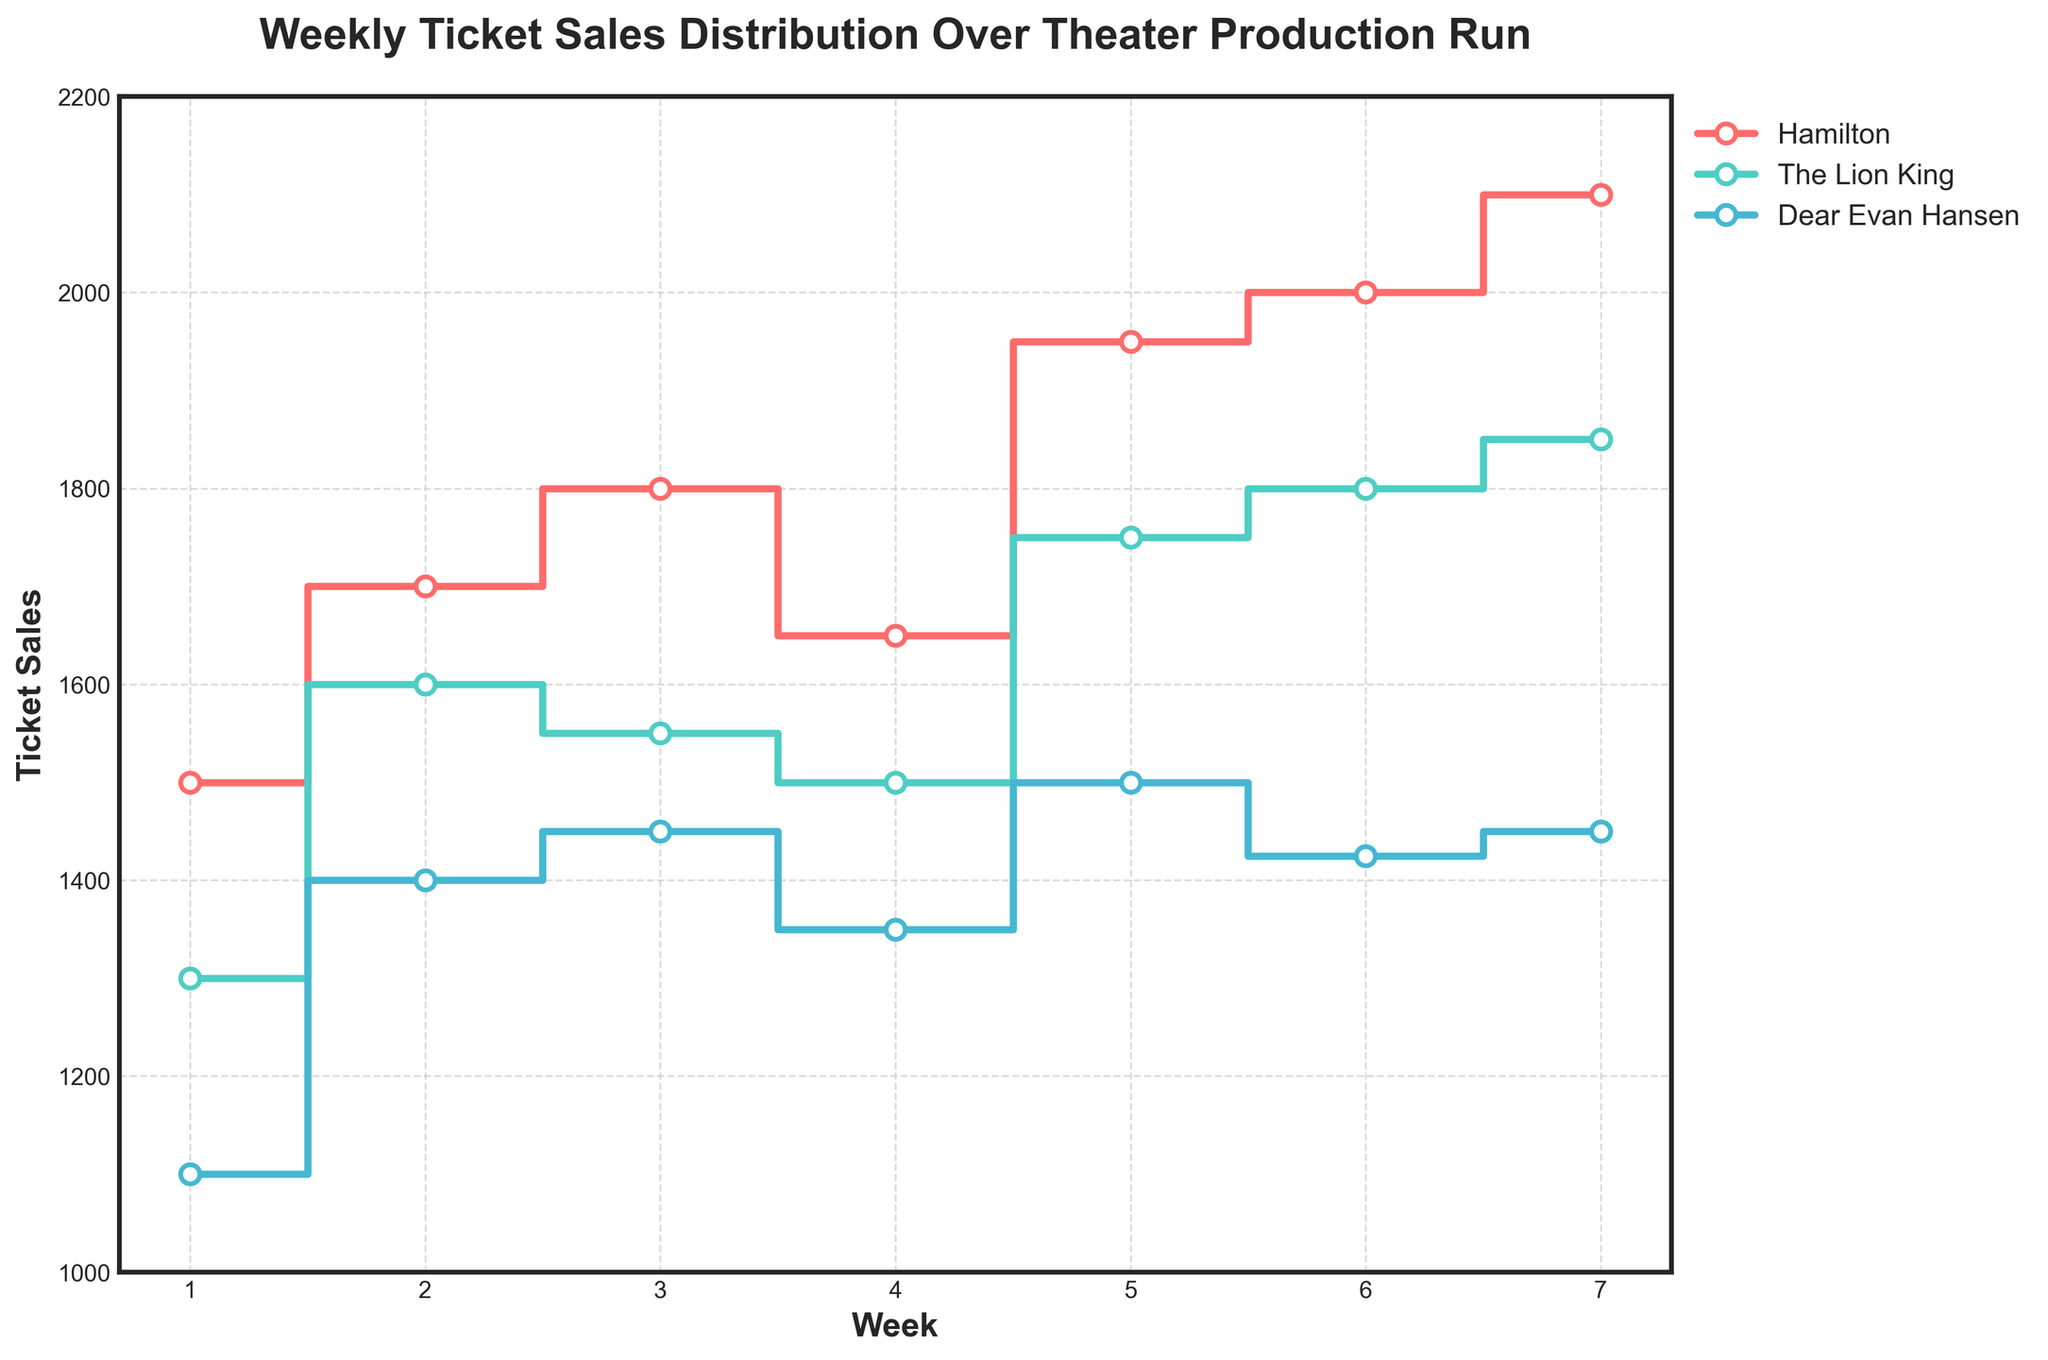What is the title of the plot? The title is usually found at the top center of the plot. Here, it is displayed in larger, bold font for emphasis.
Answer: Weekly Ticket Sales Distribution Over Theater Production Run What is the trend in ticket sales for Hamilton from Week 1 to Week 7? By observing the stair steps for Hamilton, we can see an overall increasing pattern in the y-axis values from Week 1 to Week 7, with some fluctuations.
Answer: Increasing Which week had the least ticket sales for The Lion King? To find this, locate the lowest point on the step plot for The Lion King along the y-axis and check its corresponding week on the x-axis.
Answer: Week 1 What was the approximate difference in ticket sales between Hamilton and Dear Evan Hansen in Week 6? Check the y-axis values for Hamilton and Dear Evan Hansen in Week 6 and subtract the smaller value from the larger one: 2000 (Hamilton) - 1425 (Dear Evan Hansen).
Answer: 575 What can you infer about the overall popularity of the shows based on their ticket sales trend lines? Look for patterns in the step lines: steep upward trends or consistently high values can imply popularity. Hamilton shows the steepest upward trend, suggesting it gained more popularity over time.
Answer: Hamilton is most popular Which show had the most consistent ticket sales over the weeks? To determine consistency, observe the fluctuations in the steps. The Lion King shows the least variation in its peaks and troughs, suggesting it had the most consistent sales.
Answer: The Lion King By how much did the ticket sales for Dear Evan Hansen increase from Week 1 to Week 2? Locate the y-axis values for Dear Evan Hansen in Week 1 and Week 2 and subtract: 1400 (Week 2) - 1100 (Week 1).
Answer: 300 Did any show have a week where ticket sales decreased compared to the previous week? Examine the stair steps for any downward movements. Hamilton shows a decrease from Week 3 to Week 4.
Answer: Yes, Hamilton Comparing Week 3 sales, which show sold more tickets, The Lion King or Dear Evan Hansen? Find the y-axis values for Week 3 for both shows and compare: 1550 (The Lion King) vs. 1450 (Dear Evan Hansen).
Answer: The Lion King How does the axis range help in analyzing the data? The y-axis range (1000 to 2200) ensures that all ticket sales values are clearly visible and comparably scaled, highlighting differences and trends effectively.
Answer: It helps in visual comparison 